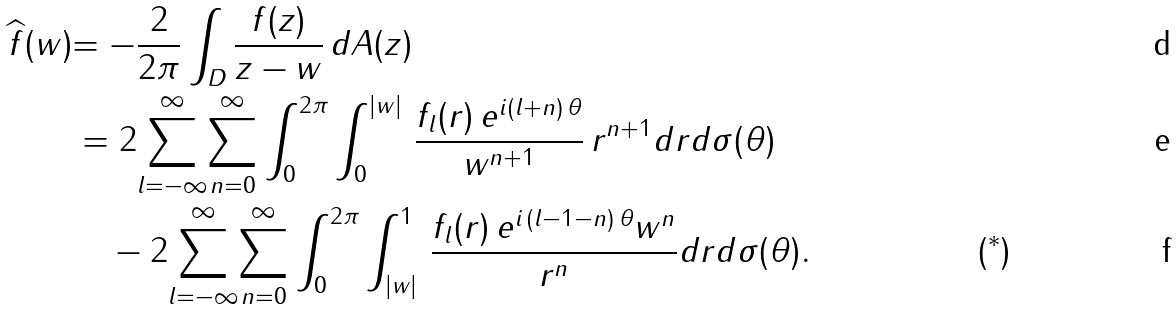Convert formula to latex. <formula><loc_0><loc_0><loc_500><loc_500>{ \widehat { f } ( w ) } & { = - \frac { 2 } { 2 \pi } } \int _ { D } \frac { f ( z ) } { z - w } \, d A ( z ) \\ & = 2 \overset { \infty } { \underset { l = - \infty } { \sum } } \overset { \infty } { \underset { n = 0 } { \sum } } \int _ { 0 } ^ { 2 \pi } \int _ { 0 } ^ { | w | } \, \frac { f _ { l } ( r ) \, e ^ { i ( l + n ) \, \theta } } { w ^ { n + 1 } } \, r ^ { n + 1 } d r d \sigma ( \theta ) \\ & \quad - 2 \overset { \infty } { \underset { l = - \infty } { \sum } } \overset { \infty } { \underset { n = 0 } { \sum } } \int _ { 0 } ^ { 2 \pi } \int _ { | w | } ^ { 1 } \, \frac { f _ { l } ( r ) \, e ^ { i \, ( l - 1 - n ) \, \theta } w ^ { n } } { r ^ { n } } d r d \sigma ( \theta ) . \, & ( ^ { * } )</formula> 